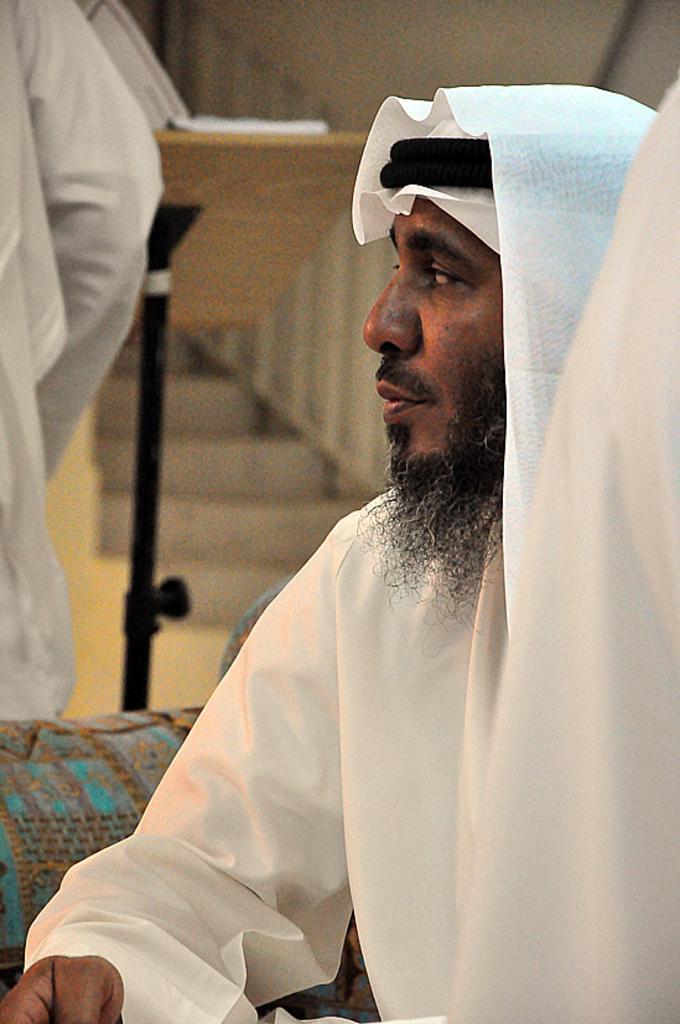How would you summarize this image in a sentence or two? Here in this picture in the front we can see a person sitting on a couch and we can see he is wearing an Islamic dress and he is having beard and beside him also we can see other people standing and behind him we can see a speech desk with a book present on it over there and we can also see a staircase present. 